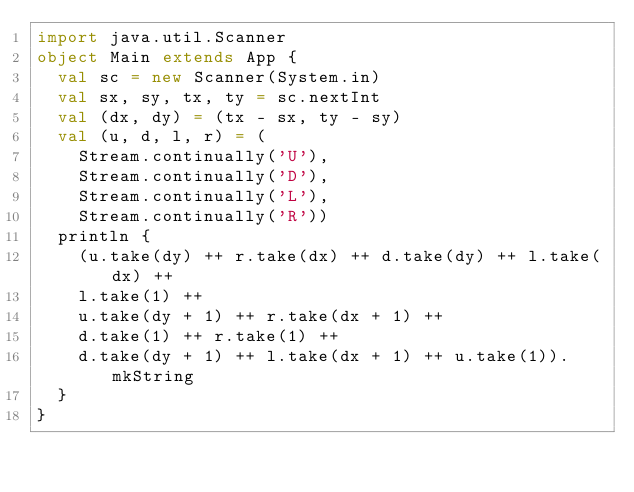Convert code to text. <code><loc_0><loc_0><loc_500><loc_500><_Scala_>import java.util.Scanner
object Main extends App {
  val sc = new Scanner(System.in)
  val sx, sy, tx, ty = sc.nextInt
  val (dx, dy) = (tx - sx, ty - sy)
  val (u, d, l, r) = (
    Stream.continually('U'),
    Stream.continually('D'),
    Stream.continually('L'),
    Stream.continually('R'))
  println {
    (u.take(dy) ++ r.take(dx) ++ d.take(dy) ++ l.take(dx) ++
    l.take(1) ++
    u.take(dy + 1) ++ r.take(dx + 1) ++
    d.take(1) ++ r.take(1) ++
    d.take(dy + 1) ++ l.take(dx + 1) ++ u.take(1)).mkString
  }
}
</code> 